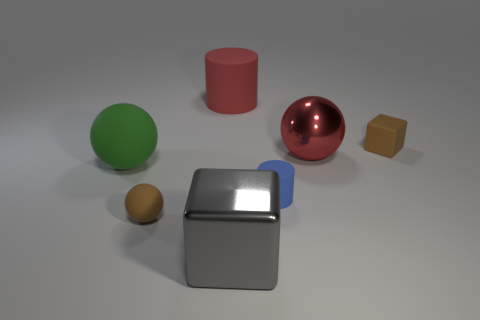Subtract all tiny rubber balls. How many balls are left? 2 Subtract all gray blocks. How many blocks are left? 1 Subtract all cylinders. How many objects are left? 5 Add 2 gray matte blocks. How many objects exist? 9 Subtract 2 balls. How many balls are left? 1 Subtract all cyan cylinders. Subtract all red balls. How many cylinders are left? 2 Subtract all gray balls. How many red blocks are left? 0 Subtract all large yellow matte blocks. Subtract all brown objects. How many objects are left? 5 Add 2 big green objects. How many big green objects are left? 3 Add 2 cyan matte balls. How many cyan matte balls exist? 2 